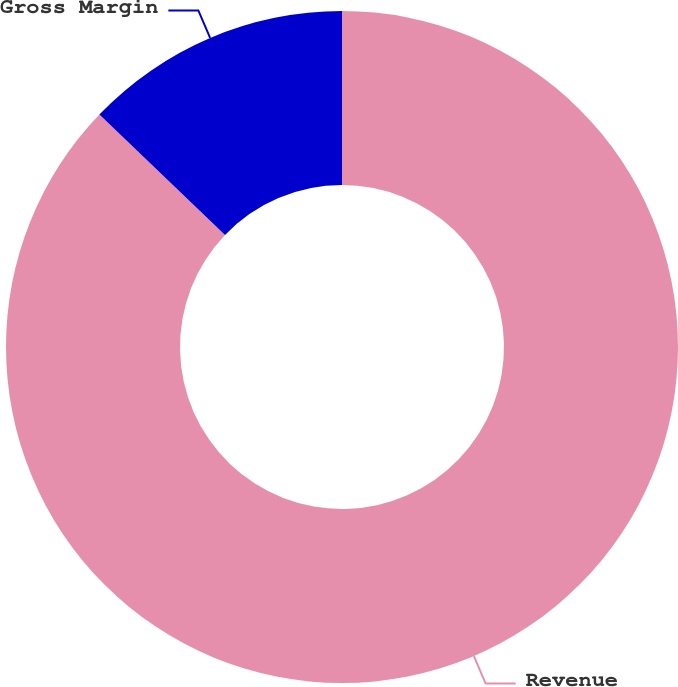Convert chart. <chart><loc_0><loc_0><loc_500><loc_500><pie_chart><fcel>Revenue<fcel>Gross Margin<nl><fcel>87.16%<fcel>12.84%<nl></chart> 